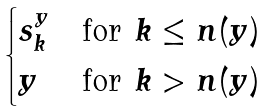Convert formula to latex. <formula><loc_0><loc_0><loc_500><loc_500>\begin{cases} s ^ { y } _ { k } & \text {for } k \leq n ( y ) \\ y & \text {for } k > n ( y ) \end{cases}</formula> 